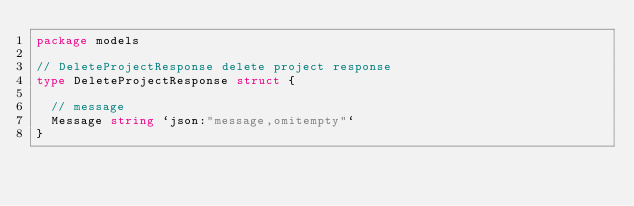Convert code to text. <code><loc_0><loc_0><loc_500><loc_500><_Go_>package models

// DeleteProjectResponse delete project response
type DeleteProjectResponse struct {

	// message
	Message string `json:"message,omitempty"`
}
</code> 